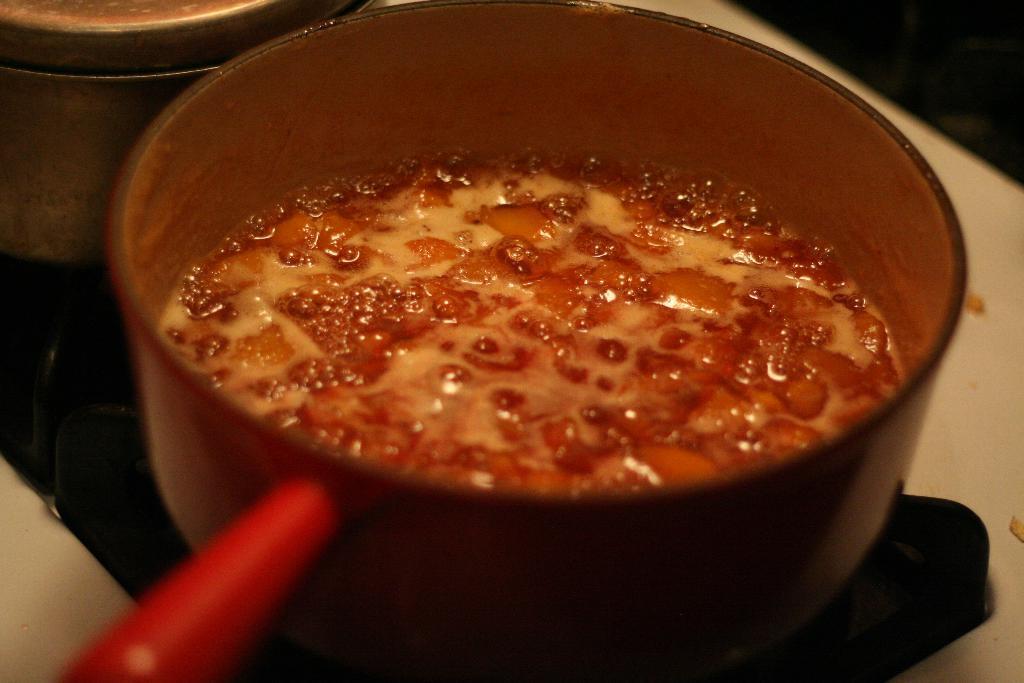Could you give a brief overview of what you see in this image? In this image we can see a stove. On that there is a pan with a food item. And there is another vessel on the stove. 